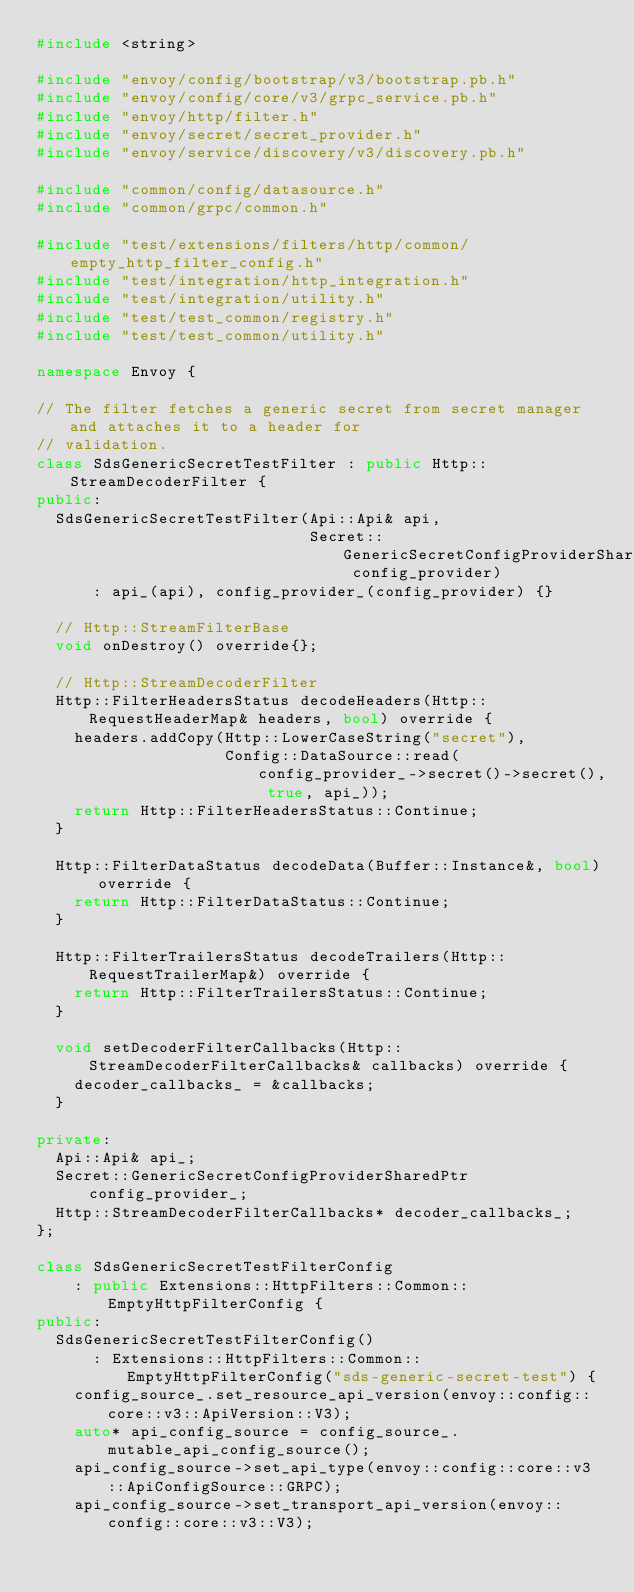Convert code to text. <code><loc_0><loc_0><loc_500><loc_500><_C++_>#include <string>

#include "envoy/config/bootstrap/v3/bootstrap.pb.h"
#include "envoy/config/core/v3/grpc_service.pb.h"
#include "envoy/http/filter.h"
#include "envoy/secret/secret_provider.h"
#include "envoy/service/discovery/v3/discovery.pb.h"

#include "common/config/datasource.h"
#include "common/grpc/common.h"

#include "test/extensions/filters/http/common/empty_http_filter_config.h"
#include "test/integration/http_integration.h"
#include "test/integration/utility.h"
#include "test/test_common/registry.h"
#include "test/test_common/utility.h"

namespace Envoy {

// The filter fetches a generic secret from secret manager and attaches it to a header for
// validation.
class SdsGenericSecretTestFilter : public Http::StreamDecoderFilter {
public:
  SdsGenericSecretTestFilter(Api::Api& api,
                             Secret::GenericSecretConfigProviderSharedPtr config_provider)
      : api_(api), config_provider_(config_provider) {}

  // Http::StreamFilterBase
  void onDestroy() override{};

  // Http::StreamDecoderFilter
  Http::FilterHeadersStatus decodeHeaders(Http::RequestHeaderMap& headers, bool) override {
    headers.addCopy(Http::LowerCaseString("secret"),
                    Config::DataSource::read(config_provider_->secret()->secret(), true, api_));
    return Http::FilterHeadersStatus::Continue;
  }

  Http::FilterDataStatus decodeData(Buffer::Instance&, bool) override {
    return Http::FilterDataStatus::Continue;
  }

  Http::FilterTrailersStatus decodeTrailers(Http::RequestTrailerMap&) override {
    return Http::FilterTrailersStatus::Continue;
  }

  void setDecoderFilterCallbacks(Http::StreamDecoderFilterCallbacks& callbacks) override {
    decoder_callbacks_ = &callbacks;
  }

private:
  Api::Api& api_;
  Secret::GenericSecretConfigProviderSharedPtr config_provider_;
  Http::StreamDecoderFilterCallbacks* decoder_callbacks_;
};

class SdsGenericSecretTestFilterConfig
    : public Extensions::HttpFilters::Common::EmptyHttpFilterConfig {
public:
  SdsGenericSecretTestFilterConfig()
      : Extensions::HttpFilters::Common::EmptyHttpFilterConfig("sds-generic-secret-test") {
    config_source_.set_resource_api_version(envoy::config::core::v3::ApiVersion::V3);
    auto* api_config_source = config_source_.mutable_api_config_source();
    api_config_source->set_api_type(envoy::config::core::v3::ApiConfigSource::GRPC);
    api_config_source->set_transport_api_version(envoy::config::core::v3::V3);</code> 